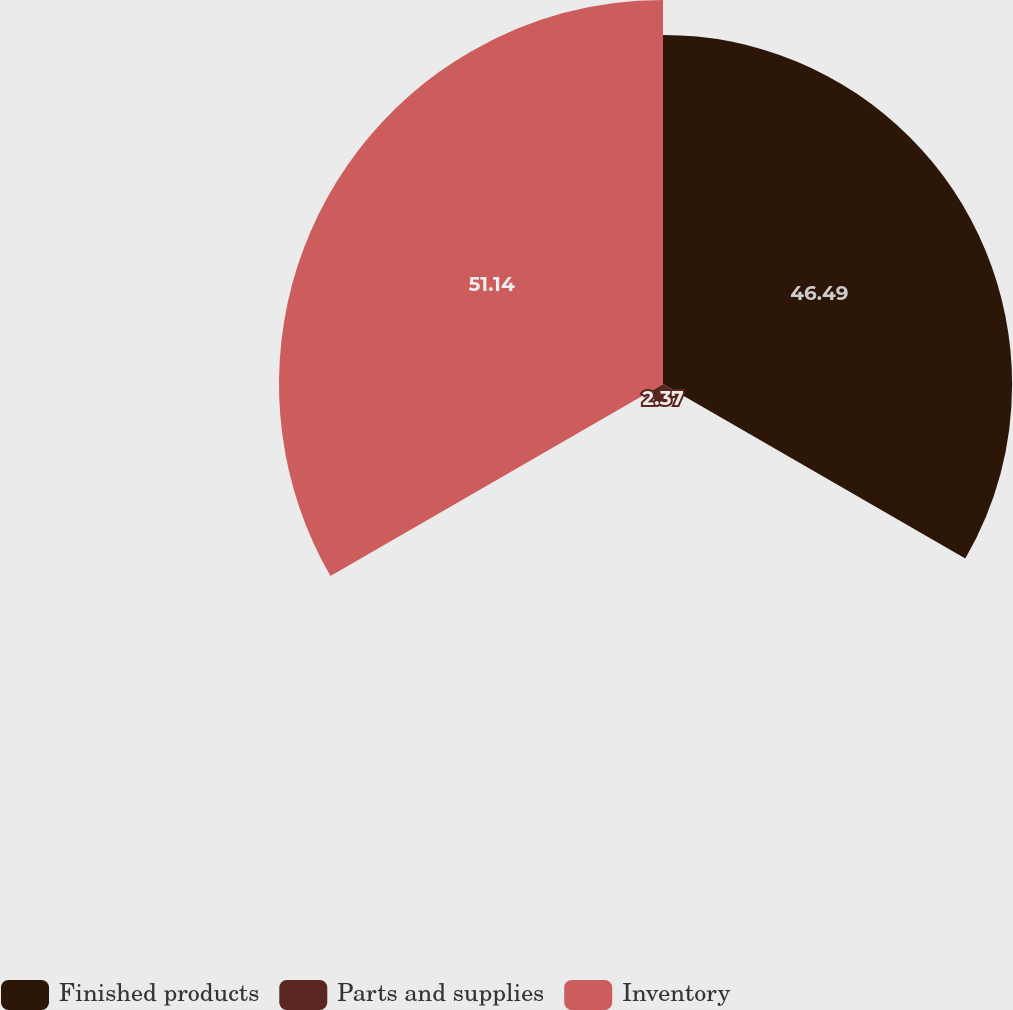<chart> <loc_0><loc_0><loc_500><loc_500><pie_chart><fcel>Finished products<fcel>Parts and supplies<fcel>Inventory<nl><fcel>46.49%<fcel>2.37%<fcel>51.14%<nl></chart> 